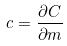<formula> <loc_0><loc_0><loc_500><loc_500>c = \frac { \partial C } { \partial m }</formula> 